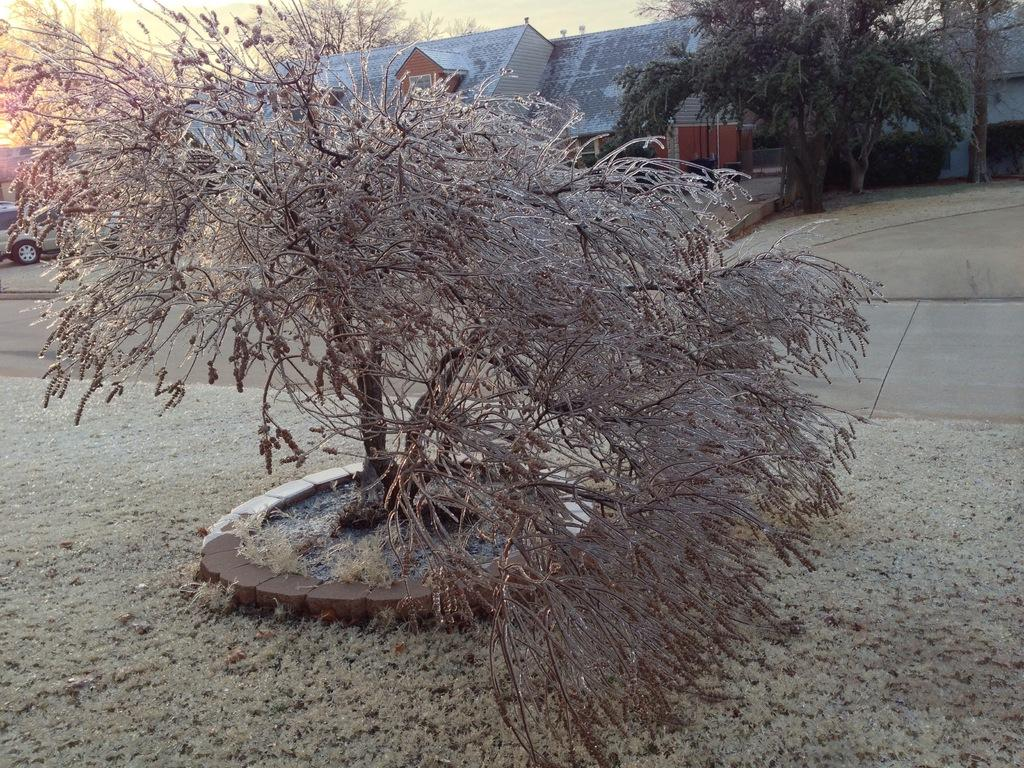What is located on the left side of the image? There is a tree on the ground on the left side of the image. What can be seen in the background of the image? There is a road, vehicles, buildings, trees, and the sky visible in the background of the image. What year is written on the tree in the image? There is no year written on the tree in the image. What song can be heard playing in the background of the image? There is no sound or music present in the image, so it is not possible to determine what song might be playing. 